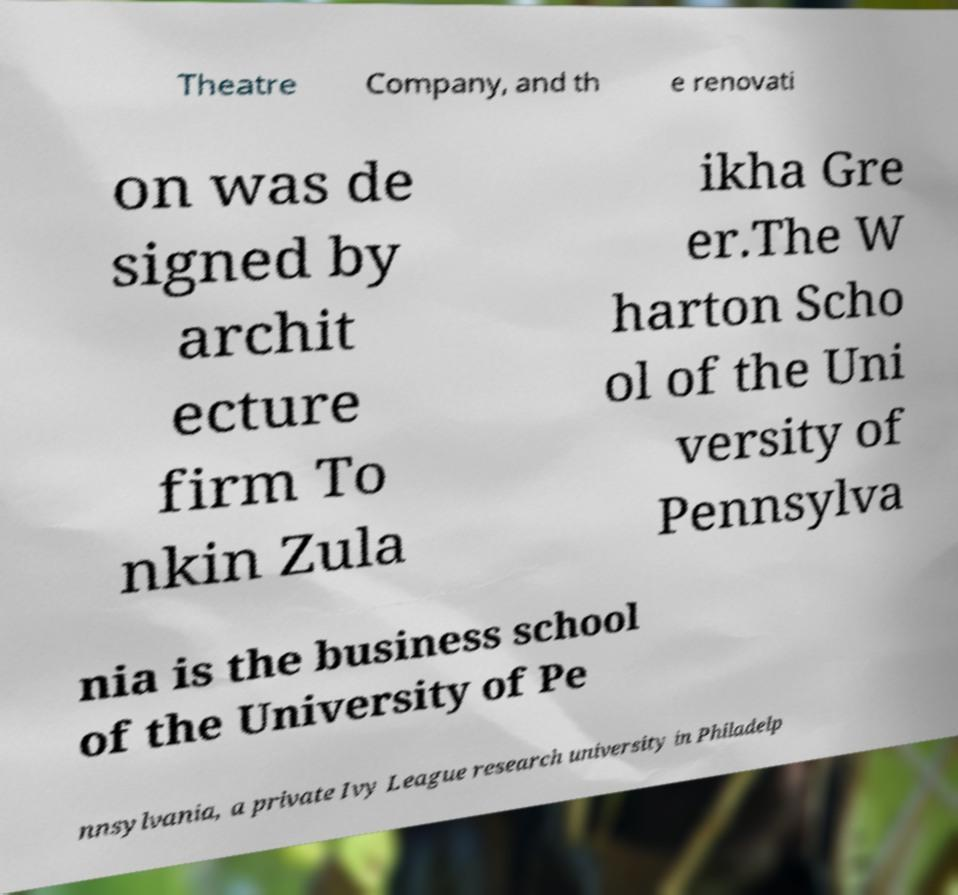Please read and relay the text visible in this image. What does it say? Theatre Company, and th e renovati on was de signed by archit ecture firm To nkin Zula ikha Gre er.The W harton Scho ol of the Uni versity of Pennsylva nia is the business school of the University of Pe nnsylvania, a private Ivy League research university in Philadelp 